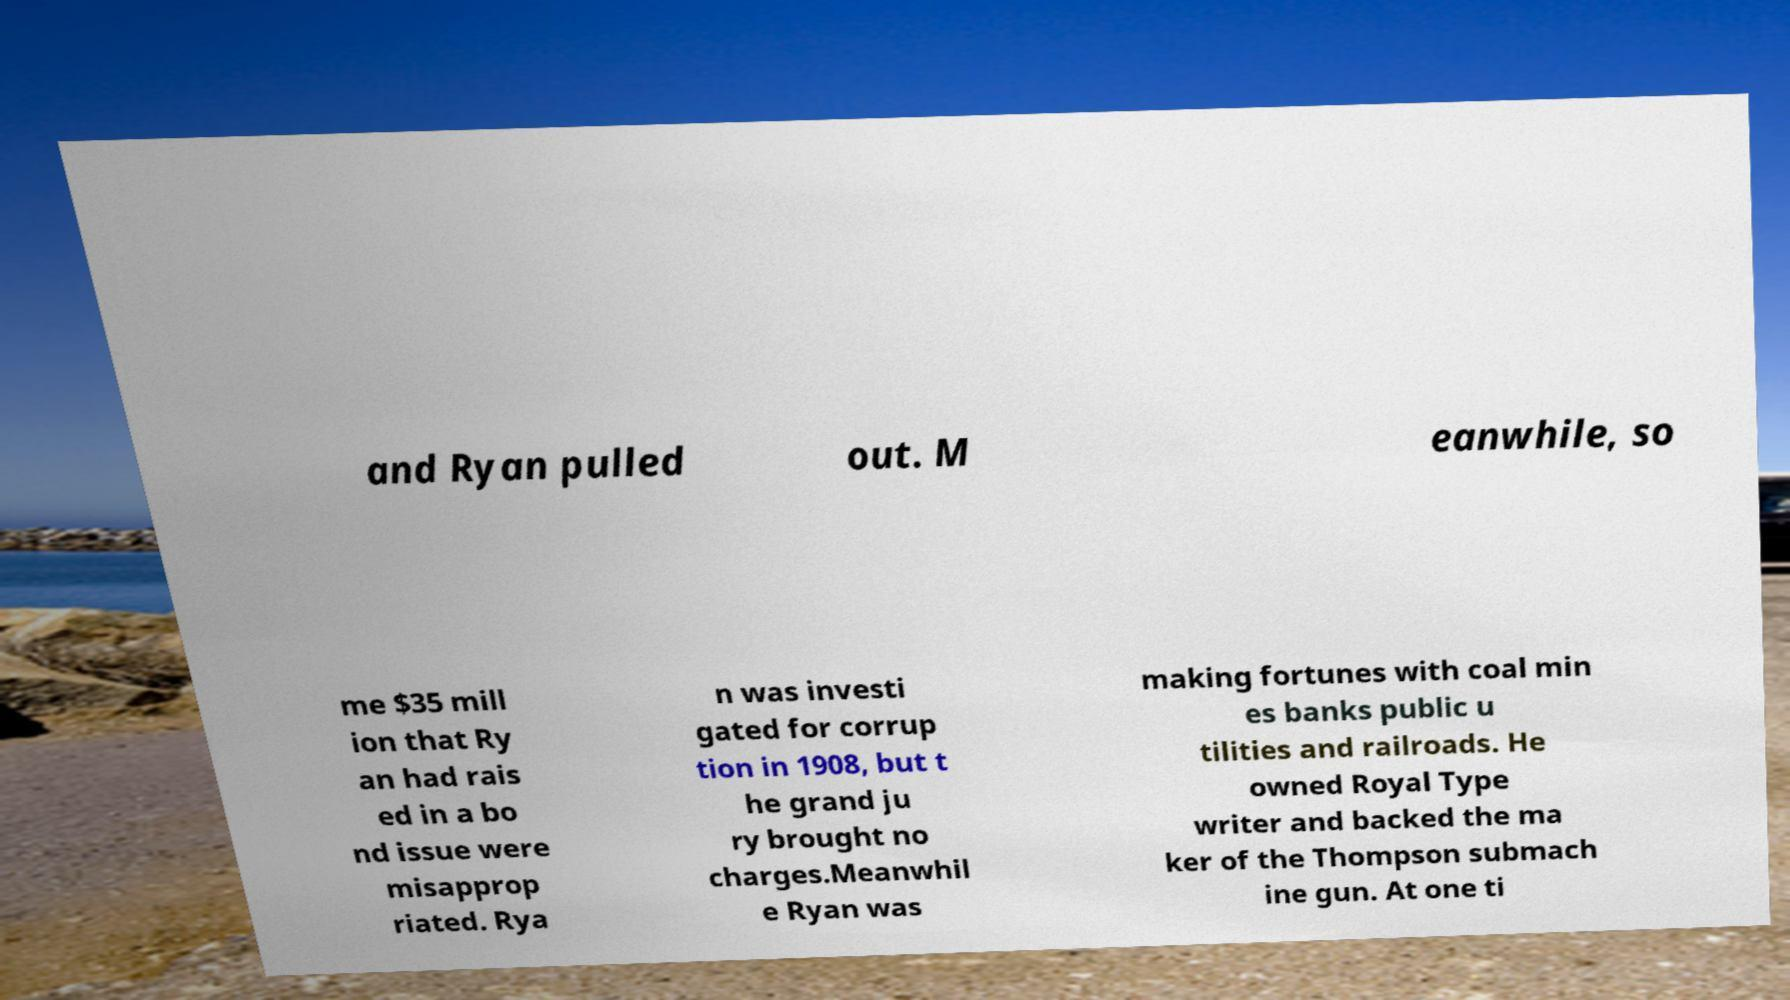Can you read and provide the text displayed in the image?This photo seems to have some interesting text. Can you extract and type it out for me? and Ryan pulled out. M eanwhile, so me $35 mill ion that Ry an had rais ed in a bo nd issue were misapprop riated. Rya n was investi gated for corrup tion in 1908, but t he grand ju ry brought no charges.Meanwhil e Ryan was making fortunes with coal min es banks public u tilities and railroads. He owned Royal Type writer and backed the ma ker of the Thompson submach ine gun. At one ti 